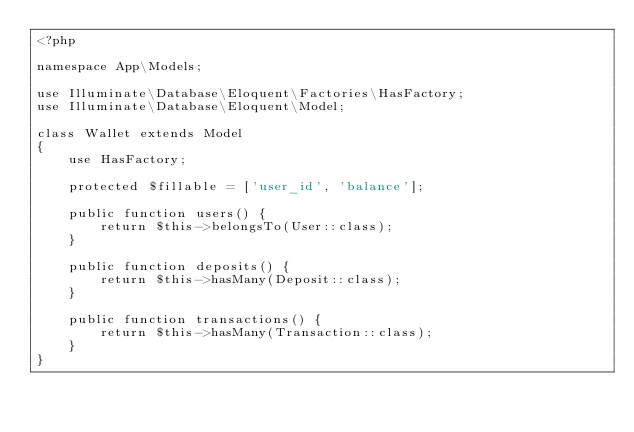Convert code to text. <code><loc_0><loc_0><loc_500><loc_500><_PHP_><?php

namespace App\Models;

use Illuminate\Database\Eloquent\Factories\HasFactory;
use Illuminate\Database\Eloquent\Model;

class Wallet extends Model
{
    use HasFactory;

    protected $fillable = ['user_id', 'balance'];

    public function users() {
        return $this->belongsTo(User::class);
    }

    public function deposits() {
        return $this->hasMany(Deposit::class);
    }

    public function transactions() {
        return $this->hasMany(Transaction::class);
    }
}
</code> 